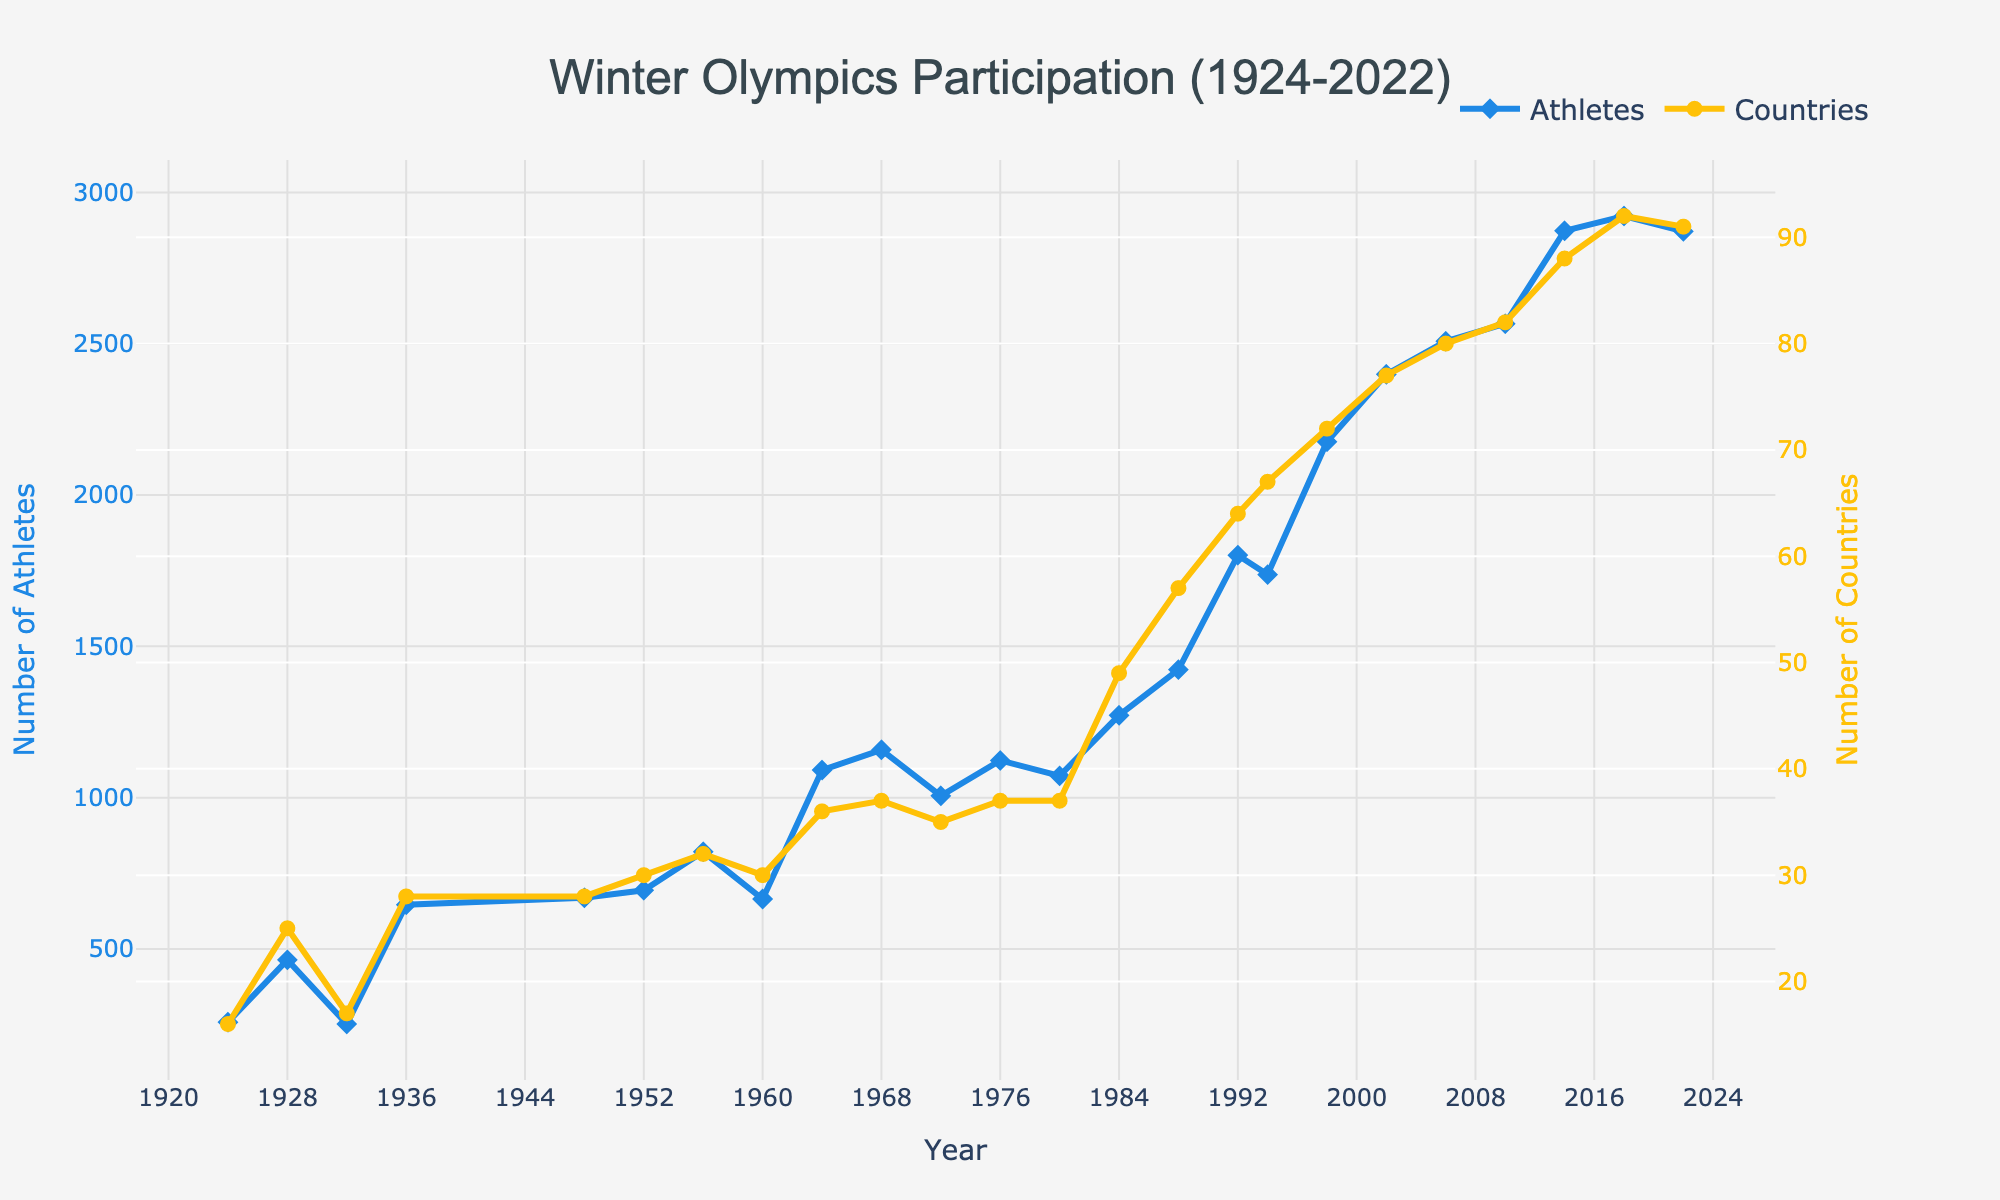What is the maximum number of countries that participated in the Winter Olympics from 1924 to 2022? Locate the highest point on the line representing the number of countries. This occurs in 2018, where the figure shows 92 countries.
Answer: 92 Which year had the notable increase in the number of athletes compared to the previous event? Compare consecutive years on the Athletes line. The largest increase can be observed between 1988 (1423) and 1992 (1801), a difference of 378 athletes.
Answer: 1992 How has the number of countries participating changed from the first Olympics in 1924 to the most recent one in 2022? Subtract the number of countries in 1924 (16) from the number in 2022 (91). This results in an increase of 75 countries over the period.
Answer: 75 more countries During which periods did the number of athletes decrease? Identify periods where the Athletes line drops. This occurs from 1928 to 1932, 1956 to 1960, and 1992 to 1994.
Answer: 1928-1932, 1956-1960, and 1992-1994 Is there a consistent upward trend in the number of countries participating over the years? Observe the general direction of the Countries line. Generally, there is an upward trend with minor setbacks.
Answer: Yes Which year had the lowest number of athletes participating, and how many were there? Locate the lowest point on the Athletes line, which is 1932 with 252 athletes.
Answer: 1932, 252 athletes How does the number of athletes in 2022 compare to the number in 1924? Subtract the number of athletes in 1924 (258) from the number in 2022 (2871). This results in 2613 more athletes in 2022.
Answer: 2613 more athletes What decade saw the largest average increase in the number of countries participating annually? Calculate average increases per decade by splitting the timeline and comparing. The 1980s (1980-1990) saw a sharp rise from 37 to 49 countries, averaging more than 1 country per year.
Answer: 1980s Which two consecutive Winter Olympics had the smallest increase in the number of participating countries? Compare increases between all consecutive Olympics. The smallest increase occurs between 1936 and 1948, where the number remains the same (28 countries).
Answer: 1936-1948 Calculate the total number of athletes who participated over the entire period from 1924 to 2022. Sum each value in the Athletes column: 258 + 464 + 252 + 646 + 669 + 694 + 821 + 665 + 1091 + 1158 + 1006 + 1123 + 1072 + 1272 + 1423 + 1801 + 1737 + 2176 + 2399 + 2508 + 2566 + 2873 + 2922 + 2871 = 39168.
Answer: 39168 